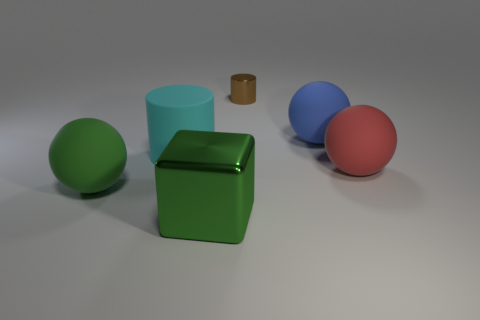How many other objects are there of the same size as the brown cylinder?
Give a very brief answer. 0. There is a rubber sphere that is in front of the red sphere; what size is it?
Your answer should be very brief. Large. There is a large green object that is left of the green block right of the cylinder in front of the brown metal cylinder; what is its material?
Make the answer very short. Rubber. Is the shape of the cyan thing the same as the tiny brown shiny thing?
Give a very brief answer. Yes. How many shiny things are blue balls or tiny yellow blocks?
Provide a succinct answer. 0. How many big blue rubber spheres are there?
Ensure brevity in your answer.  1. What is the color of the block that is the same size as the cyan cylinder?
Provide a short and direct response. Green. Is the green metallic object the same size as the blue rubber sphere?
Make the answer very short. Yes. Does the brown metal thing have the same size as the metal thing that is in front of the blue rubber sphere?
Make the answer very short. No. What color is the ball that is in front of the big cyan rubber cylinder and to the right of the big metal cube?
Your response must be concise. Red. 